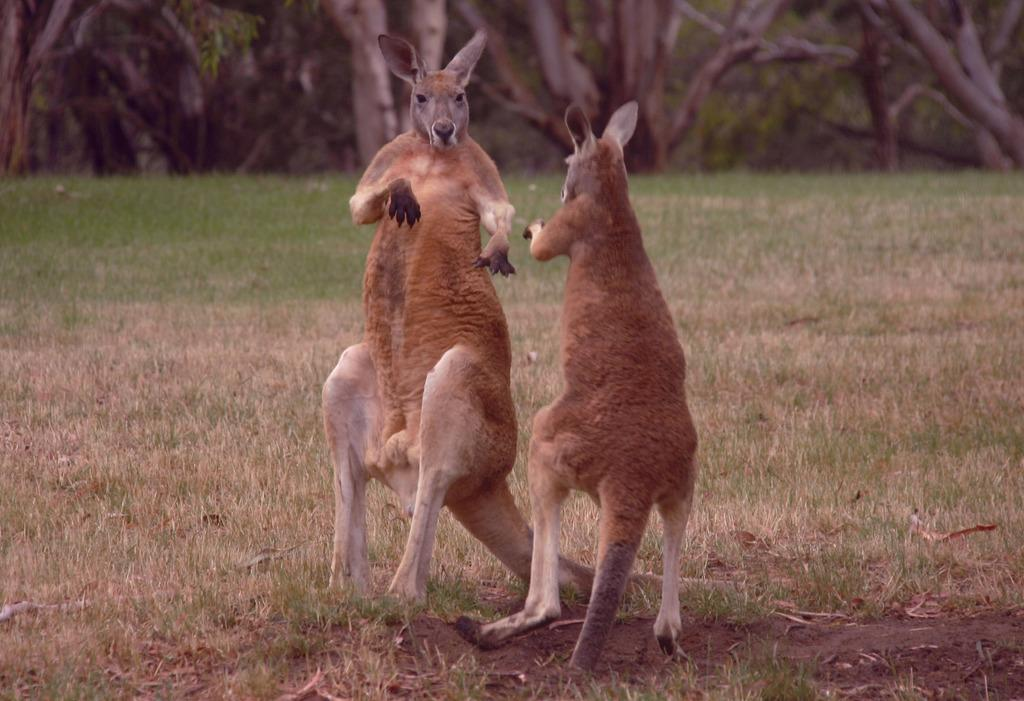What animals are present in the image? There are two kangaroos in the image. Where are the kangaroos located? The kangaroos are on the ground. What is the color of the kangaroos? The kangaroos are brown in color. What type of vegetation is visible on the ground? There is grass visible on the ground. What can be seen in the background of the image? There are trees in the background of the image. What type of breakfast is the kangaroo eating in the image? There is no indication in the image that the kangaroos are eating breakfast, as they are not shown interacting with any food items. 